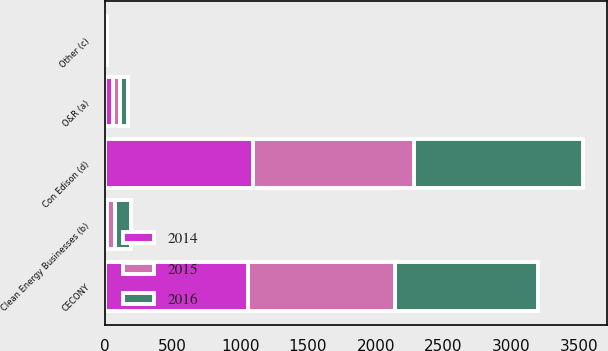Convert chart to OTSL. <chart><loc_0><loc_0><loc_500><loc_500><stacked_bar_chart><ecel><fcel>CECONY<fcel>O&R (a)<fcel>Clean Energy Businesses (b)<fcel>Other (c)<fcel>Con Edison (d)<nl><fcel>2016<fcel>1056<fcel>59<fcel>118<fcel>8<fcel>1245<nl><fcel>2015<fcel>1084<fcel>52<fcel>59<fcel>2<fcel>1193<nl><fcel>2014<fcel>1058<fcel>60<fcel>17<fcel>9<fcel>1092<nl></chart> 